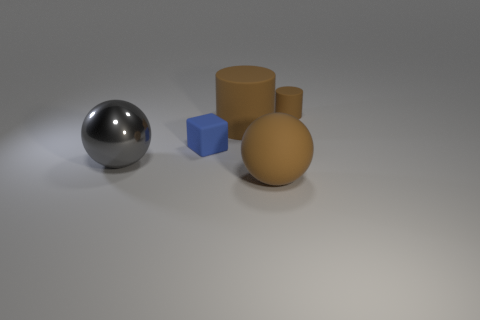How many other things are the same color as the big matte cylinder?
Make the answer very short. 2. Is there a small matte cylinder that has the same color as the large matte ball?
Your response must be concise. Yes. There is a big ball on the left side of the small blue block right of the metal ball; what is its material?
Offer a terse response. Metal. There is a rubber thing that is in front of the blue rubber object; is it the same shape as the large shiny object?
Provide a succinct answer. Yes. The other tiny thing that is made of the same material as the blue object is what color?
Provide a succinct answer. Brown. What is the material of the big sphere to the left of the tiny cube?
Offer a terse response. Metal. There is a gray object; is its shape the same as the large matte thing in front of the block?
Keep it short and to the point. Yes. What material is the thing that is in front of the cube and behind the large brown ball?
Your answer should be compact. Metal. There is a rubber sphere that is the same size as the metal thing; what color is it?
Offer a very short reply. Brown. Does the gray sphere have the same material as the brown object that is in front of the matte block?
Make the answer very short. No. 